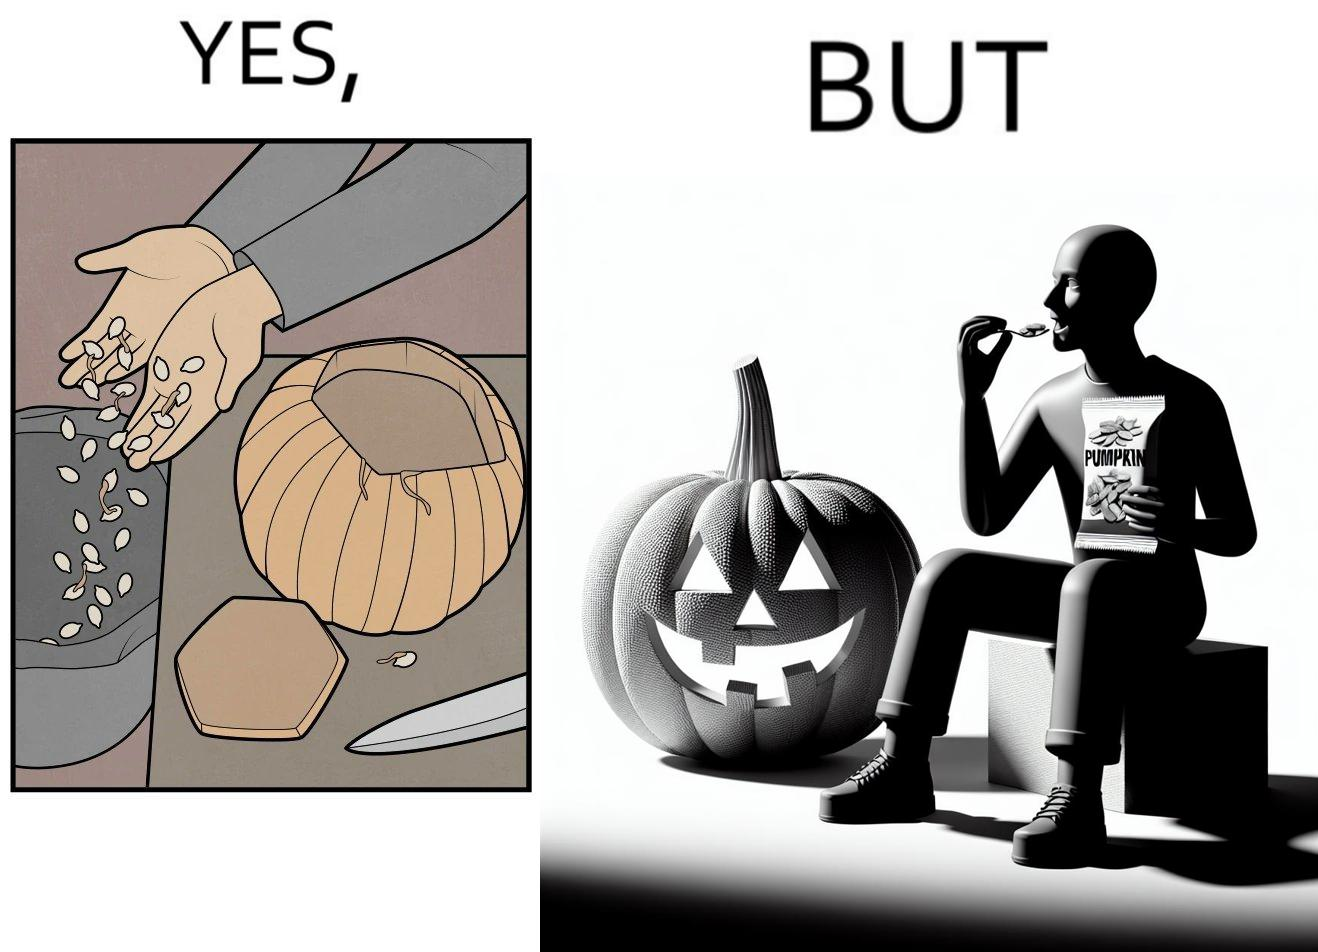Describe the contrast between the left and right parts of this image. In the left part of the image: a person removing seeds from the pumpkin In the right part of the image: a person eating packaged pumpkin seeds having a pumpkin carved in the shape of a jack-o'-lantern, used in halloween 